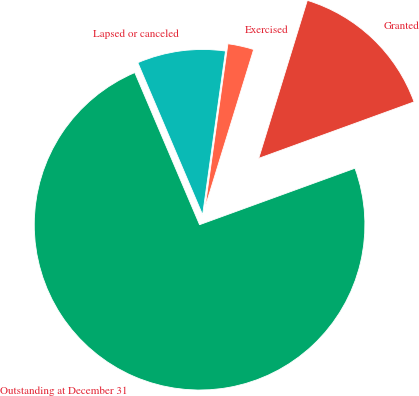Convert chart. <chart><loc_0><loc_0><loc_500><loc_500><pie_chart><fcel>Outstanding at December 31<fcel>Granted<fcel>Exercised<fcel>Lapsed or canceled<nl><fcel>74.14%<fcel>14.7%<fcel>2.54%<fcel>8.62%<nl></chart> 